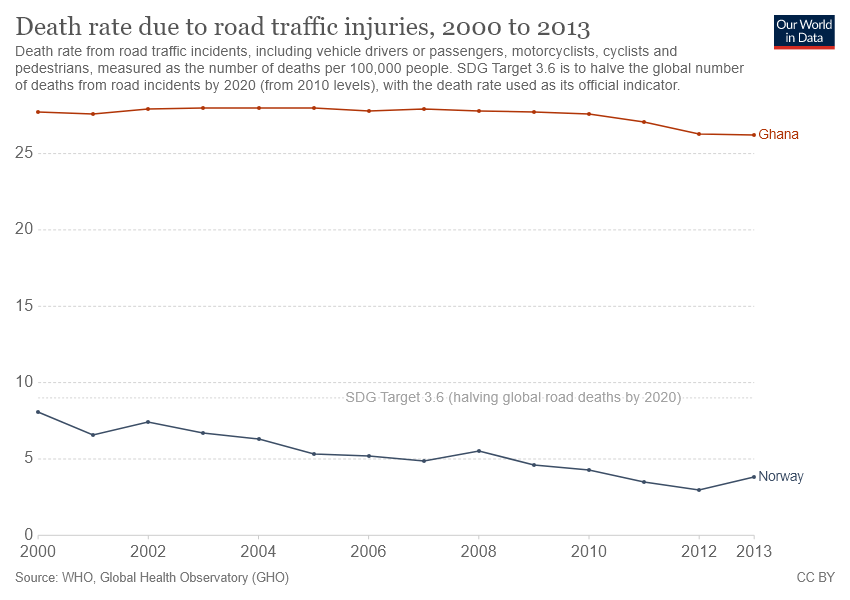Give some essential details in this illustration. According to data from the year 2000, the death rate due to road traffic injuries in Norway and Ghana was greater than 5. Norway is represented by navy blue in the color code system. 